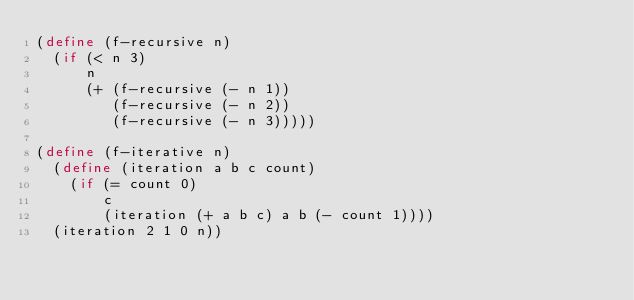Convert code to text. <code><loc_0><loc_0><loc_500><loc_500><_Scheme_>(define (f-recursive n)
  (if (< n 3)
      n
      (+ (f-recursive (- n 1))
         (f-recursive (- n 2))
         (f-recursive (- n 3)))))

(define (f-iterative n)
  (define (iteration a b c count)
    (if (= count 0)
        c
        (iteration (+ a b c) a b (- count 1))))
  (iteration 2 1 0 n))
</code> 